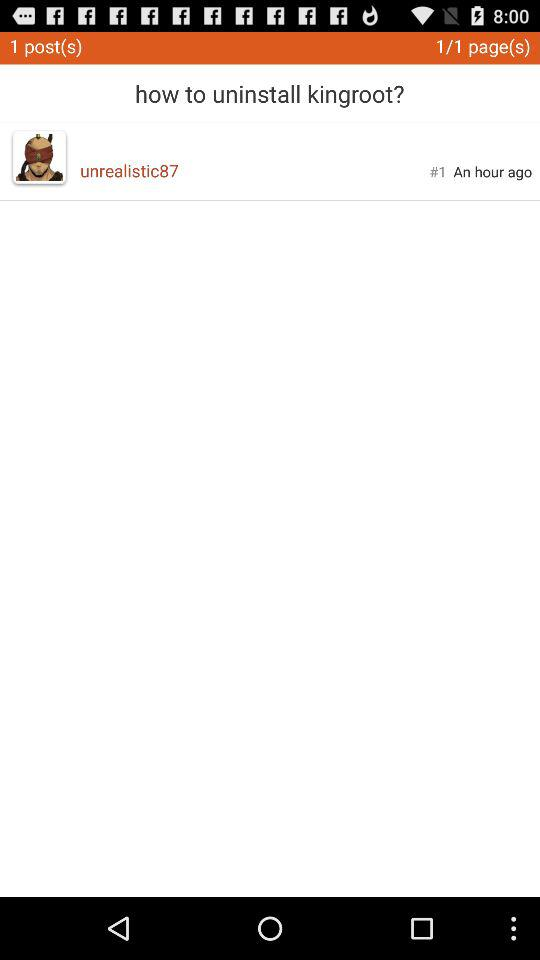What is the total number of posts? The total number of posts is 1. 